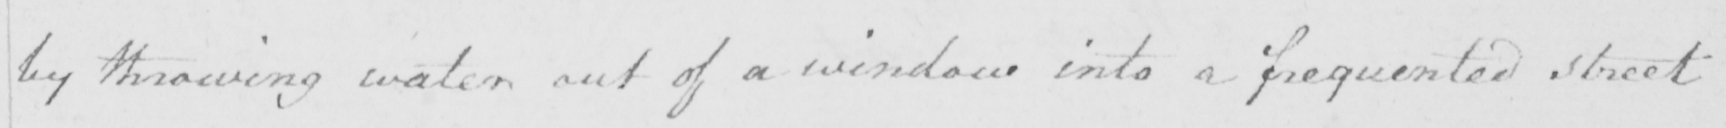Can you read and transcribe this handwriting? by throwing water out of a window into a frequented street 